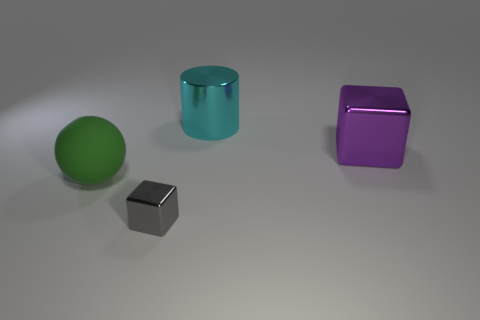There is a block that is behind the gray metallic object that is in front of the large block; what size is it?
Give a very brief answer. Large. What is the size of the matte thing?
Keep it short and to the point. Large. There is a big object behind the large metal block; does it have the same color as the big object that is in front of the purple block?
Your response must be concise. No. How many other objects are the same material as the large green thing?
Your answer should be compact. 0. Is there a large purple metal cube?
Your answer should be very brief. Yes. Is the small gray thing in front of the matte ball made of the same material as the big green sphere?
Your answer should be compact. No. There is another purple object that is the same shape as the small metallic object; what is its material?
Keep it short and to the point. Metal. Are there fewer blue metal balls than small blocks?
Provide a succinct answer. Yes. Do the tiny object in front of the big purple shiny object and the matte thing have the same color?
Ensure brevity in your answer.  No. There is a tiny thing that is the same material as the big cube; what color is it?
Make the answer very short. Gray. 